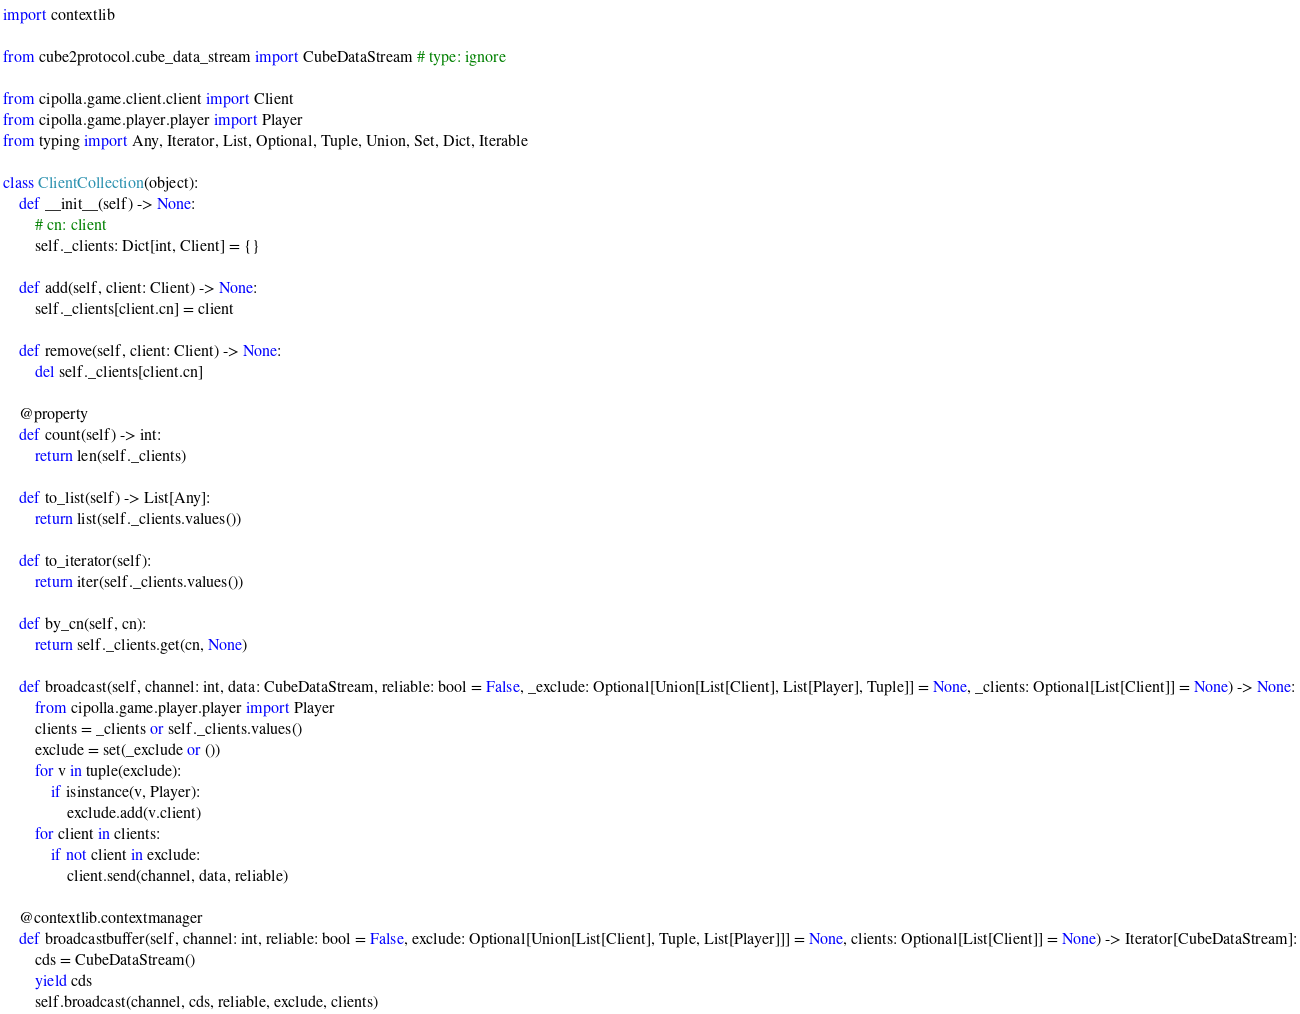Convert code to text. <code><loc_0><loc_0><loc_500><loc_500><_Python_>import contextlib

from cube2protocol.cube_data_stream import CubeDataStream # type: ignore

from cipolla.game.client.client import Client
from cipolla.game.player.player import Player
from typing import Any, Iterator, List, Optional, Tuple, Union, Set, Dict, Iterable

class ClientCollection(object):
    def __init__(self) -> None:
        # cn: client
        self._clients: Dict[int, Client] = {}

    def add(self, client: Client) -> None:
        self._clients[client.cn] = client

    def remove(self, client: Client) -> None:
        del self._clients[client.cn]

    @property
    def count(self) -> int:
        return len(self._clients)

    def to_list(self) -> List[Any]:
        return list(self._clients.values())

    def to_iterator(self):
        return iter(self._clients.values())

    def by_cn(self, cn):
        return self._clients.get(cn, None)

    def broadcast(self, channel: int, data: CubeDataStream, reliable: bool = False, _exclude: Optional[Union[List[Client], List[Player], Tuple]] = None, _clients: Optional[List[Client]] = None) -> None:
        from cipolla.game.player.player import Player
        clients = _clients or self._clients.values()
        exclude = set(_exclude or ())
        for v in tuple(exclude):
            if isinstance(v, Player):
                exclude.add(v.client)
        for client in clients:
            if not client in exclude:
                client.send(channel, data, reliable)

    @contextlib.contextmanager
    def broadcastbuffer(self, channel: int, reliable: bool = False, exclude: Optional[Union[List[Client], Tuple, List[Player]]] = None, clients: Optional[List[Client]] = None) -> Iterator[CubeDataStream]:
        cds = CubeDataStream()
        yield cds
        self.broadcast(channel, cds, reliable, exclude, clients)
</code> 